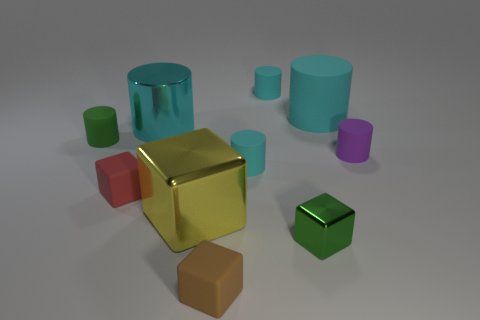The cyan cylinder that is both in front of the big cyan matte cylinder and to the right of the small brown cube is made of what material?
Make the answer very short. Rubber. There is a tiny matte object that is behind the green cylinder; what color is it?
Make the answer very short. Cyan. Is the number of green cylinders behind the big cyan rubber thing greater than the number of small purple matte things?
Provide a short and direct response. No. How many other things are there of the same size as the green matte cylinder?
Your answer should be compact. 6. What number of cylinders are on the left side of the tiny brown block?
Your answer should be very brief. 2. Is the number of tiny green things that are to the left of the small green metal object the same as the number of green objects in front of the small purple rubber cylinder?
Offer a terse response. Yes. What size is the green metallic object that is the same shape as the small red object?
Ensure brevity in your answer.  Small. There is a small green thing on the right side of the red block; what shape is it?
Offer a terse response. Cube. Does the cylinder left of the tiny red thing have the same material as the red cube on the right side of the green rubber thing?
Make the answer very short. Yes. What is the shape of the small green shiny object?
Your answer should be very brief. Cube. 